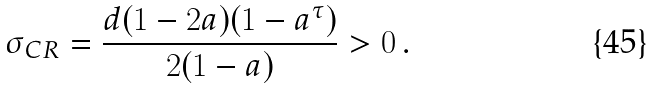Convert formula to latex. <formula><loc_0><loc_0><loc_500><loc_500>\sigma _ { C R } = \frac { d ( 1 - 2 a ) ( 1 - a ^ { \tau } ) } { 2 ( 1 - a ) } > 0 \, .</formula> 